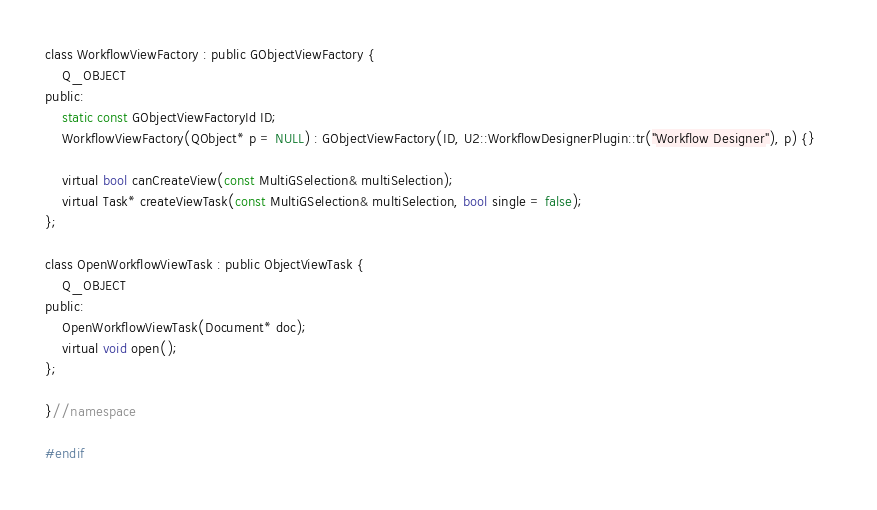Convert code to text. <code><loc_0><loc_0><loc_500><loc_500><_C_>
class WorkflowViewFactory : public GObjectViewFactory {
    Q_OBJECT
public:
    static const GObjectViewFactoryId ID;
    WorkflowViewFactory(QObject* p = NULL) : GObjectViewFactory(ID, U2::WorkflowDesignerPlugin::tr("Workflow Designer"), p) {}    

    virtual bool canCreateView(const MultiGSelection& multiSelection);
    virtual Task* createViewTask(const MultiGSelection& multiSelection, bool single = false);
};

class OpenWorkflowViewTask : public ObjectViewTask {
    Q_OBJECT
public:
    OpenWorkflowViewTask(Document* doc);
    virtual void open();
};

}//namespace

#endif
</code> 